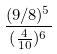<formula> <loc_0><loc_0><loc_500><loc_500>\frac { ( 9 / 8 ) ^ { 5 } } { ( \frac { 4 } { 1 0 } ) ^ { 6 } }</formula> 